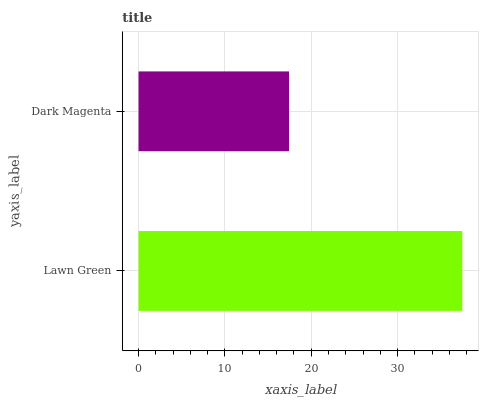Is Dark Magenta the minimum?
Answer yes or no. Yes. Is Lawn Green the maximum?
Answer yes or no. Yes. Is Dark Magenta the maximum?
Answer yes or no. No. Is Lawn Green greater than Dark Magenta?
Answer yes or no. Yes. Is Dark Magenta less than Lawn Green?
Answer yes or no. Yes. Is Dark Magenta greater than Lawn Green?
Answer yes or no. No. Is Lawn Green less than Dark Magenta?
Answer yes or no. No. Is Lawn Green the high median?
Answer yes or no. Yes. Is Dark Magenta the low median?
Answer yes or no. Yes. Is Dark Magenta the high median?
Answer yes or no. No. Is Lawn Green the low median?
Answer yes or no. No. 